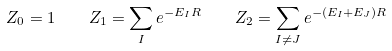Convert formula to latex. <formula><loc_0><loc_0><loc_500><loc_500>Z _ { 0 } = 1 \quad Z _ { 1 } = \sum _ { I } e ^ { - E _ { I } R } \quad Z _ { 2 } = \sum _ { I \ne J } e ^ { - ( E _ { I } + E _ { J } ) R }</formula> 